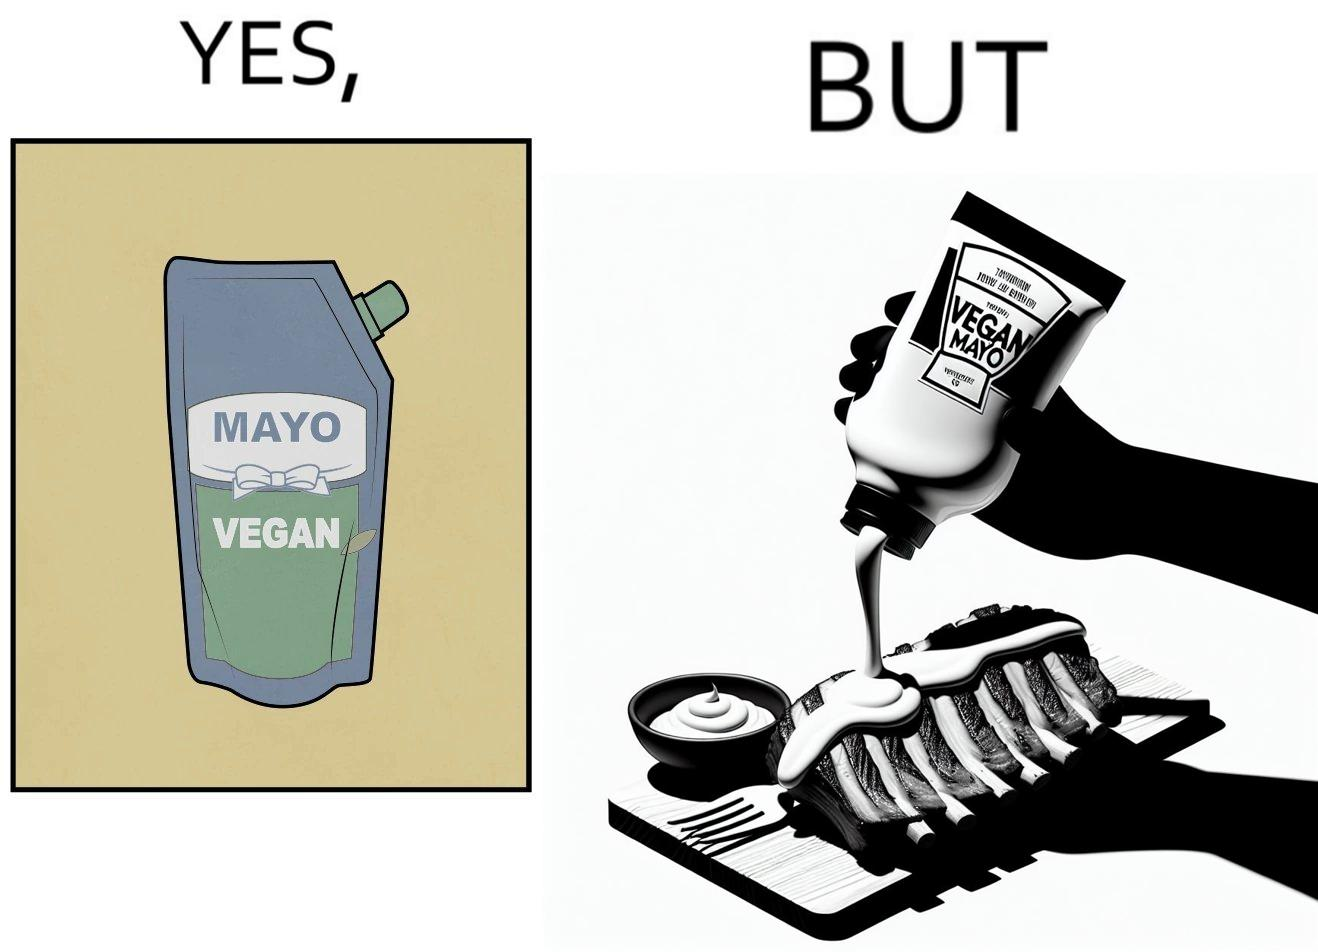Is this a satirical image? Yes, this image is satirical. 